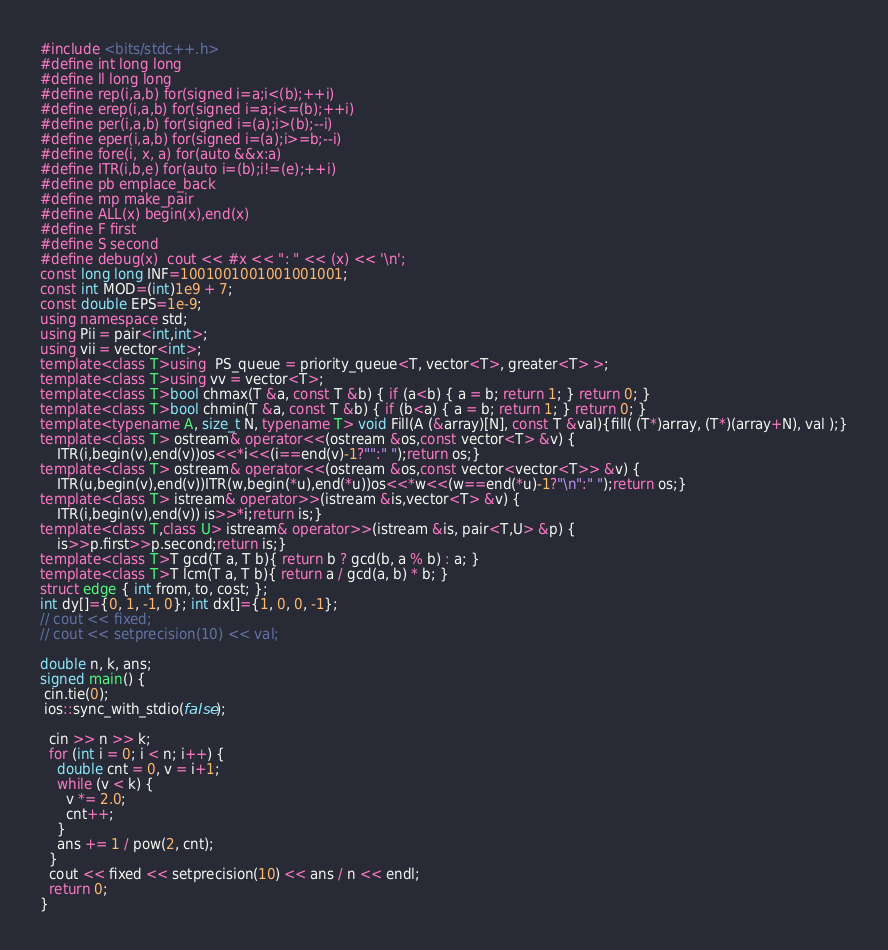Convert code to text. <code><loc_0><loc_0><loc_500><loc_500><_C++_>#include <bits/stdc++.h>
#define int long long
#define ll long long 
#define rep(i,a,b) for(signed i=a;i<(b);++i)
#define erep(i,a,b) for(signed i=a;i<=(b);++i)
#define per(i,a,b) for(signed i=(a);i>(b);--i)
#define eper(i,a,b) for(signed i=(a);i>=b;--i)
#define fore(i, x, a) for(auto &&x:a) 
#define ITR(i,b,e) for(auto i=(b);i!=(e);++i)
#define pb emplace_back
#define mp make_pair
#define ALL(x) begin(x),end(x)
#define F first
#define S second
#define debug(x)  cout << #x << ": " << (x) << '\n';
const long long INF=1001001001001001001;
const int MOD=(int)1e9 + 7;
const double EPS=1e-9;
using namespace std;
using Pii = pair<int,int>;
using vii = vector<int>;
template<class T>using  PS_queue = priority_queue<T, vector<T>, greater<T> >;
template<class T>using vv = vector<T>;
template<class T>bool chmax(T &a, const T &b) { if (a<b) { a = b; return 1; } return 0; }
template<class T>bool chmin(T &a, const T &b) { if (b<a) { a = b; return 1; } return 0; }
template<typename A, size_t N, typename T> void Fill(A (&array)[N], const T &val){fill( (T*)array, (T*)(array+N), val );}
template<class T> ostream& operator<<(ostream &os,const vector<T> &v) {
    ITR(i,begin(v),end(v))os<<*i<<(i==end(v)-1?"":" ");return os;}
template<class T> ostream& operator<<(ostream &os,const vector<vector<T>> &v) {
    ITR(u,begin(v),end(v))ITR(w,begin(*u),end(*u))os<<*w<<(w==end(*u)-1?"\n":" ");return os;}
template<class T> istream& operator>>(istream &is,vector<T> &v) {
    ITR(i,begin(v),end(v)) is>>*i;return is;}
template<class T,class U> istream& operator>>(istream &is, pair<T,U> &p) {
    is>>p.first>>p.second;return is;}
template<class T>T gcd(T a, T b){ return b ? gcd(b, a % b) : a; }
template<class T>T lcm(T a, T b){ return a / gcd(a, b) * b; }
struct edge { int from, to, cost; };
int dy[]={0, 1, -1, 0}; int dx[]={1, 0, 0, -1};
// cout << fixed;
// cout << setprecision(10) << val;

double n, k, ans;
signed main() {
 cin.tie(0);
 ios::sync_with_stdio(false);

  cin >> n >> k;
  for (int i = 0; i < n; i++) {
    double cnt = 0, v = i+1;
    while (v < k) {
      v *= 2.0;
      cnt++;
    }
    ans += 1 / pow(2, cnt);
  }
  cout << fixed << setprecision(10) << ans / n << endl;
  return 0;
}


</code> 